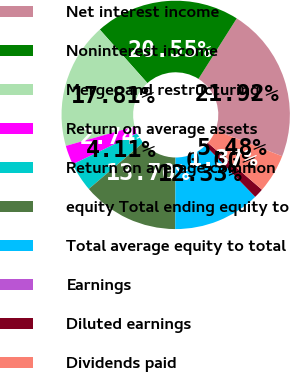<chart> <loc_0><loc_0><loc_500><loc_500><pie_chart><fcel>Net interest income<fcel>Noninterest income<fcel>Merger and restructuring<fcel>Return on average assets<fcel>Return on average common<fcel>equity Total ending equity to<fcel>Total average equity to total<fcel>Earnings<fcel>Diluted earnings<fcel>Dividends paid<nl><fcel>21.92%<fcel>20.55%<fcel>17.81%<fcel>2.74%<fcel>4.11%<fcel>13.7%<fcel>12.33%<fcel>0.0%<fcel>1.37%<fcel>5.48%<nl></chart> 